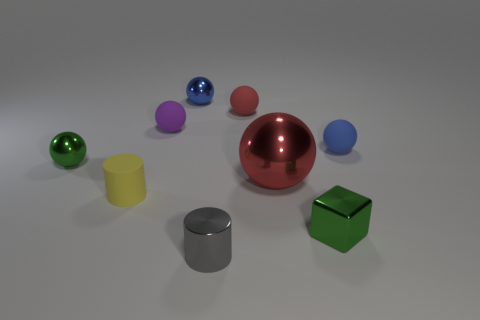What materials do the objects in the image appear to be made of? The objects in the image seem to display a variety of materials, including metallic for the silver cylinder and the shiny red sphere, as well as matte surfaces that might suggest plastic or painted metal for the other colored objects. 